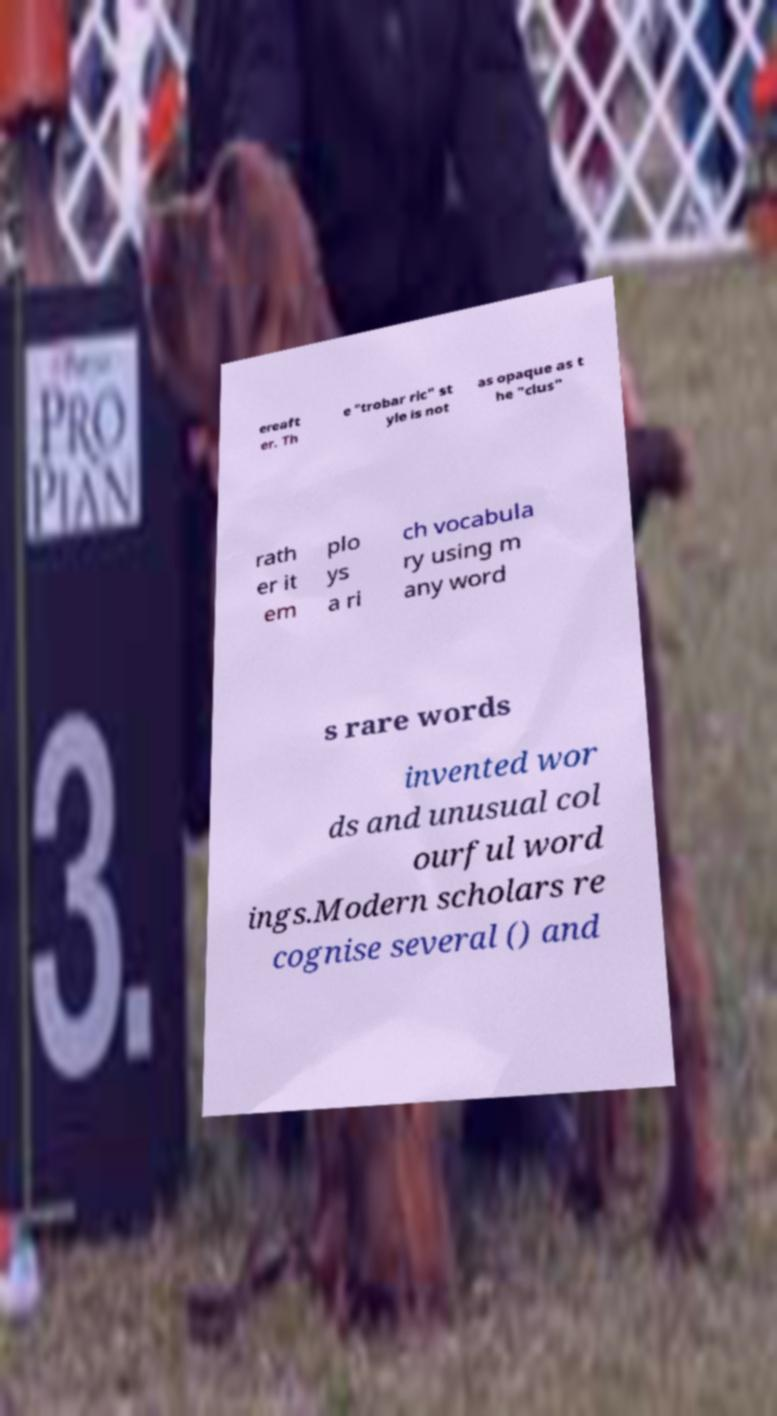Please identify and transcribe the text found in this image. ereaft er. Th e "trobar ric" st yle is not as opaque as t he "clus" rath er it em plo ys a ri ch vocabula ry using m any word s rare words invented wor ds and unusual col ourful word ings.Modern scholars re cognise several () and 